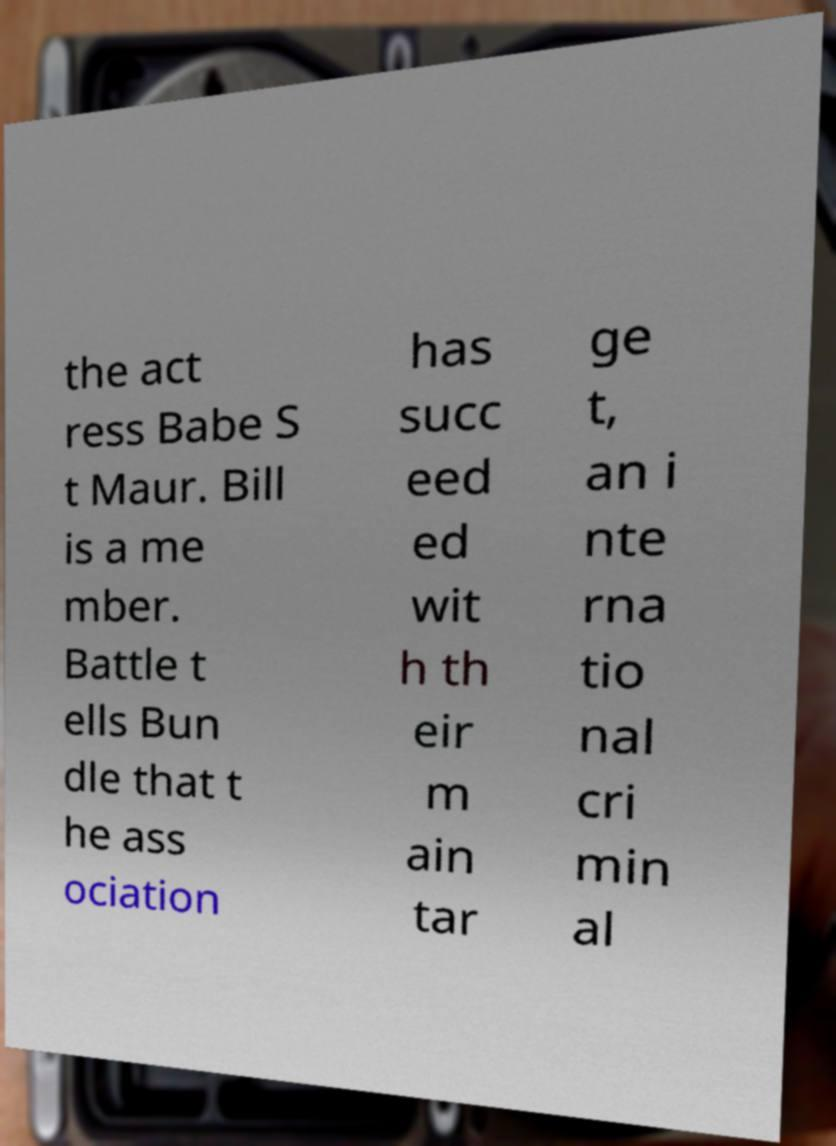For documentation purposes, I need the text within this image transcribed. Could you provide that? the act ress Babe S t Maur. Bill is a me mber. Battle t ells Bun dle that t he ass ociation has succ eed ed wit h th eir m ain tar ge t, an i nte rna tio nal cri min al 